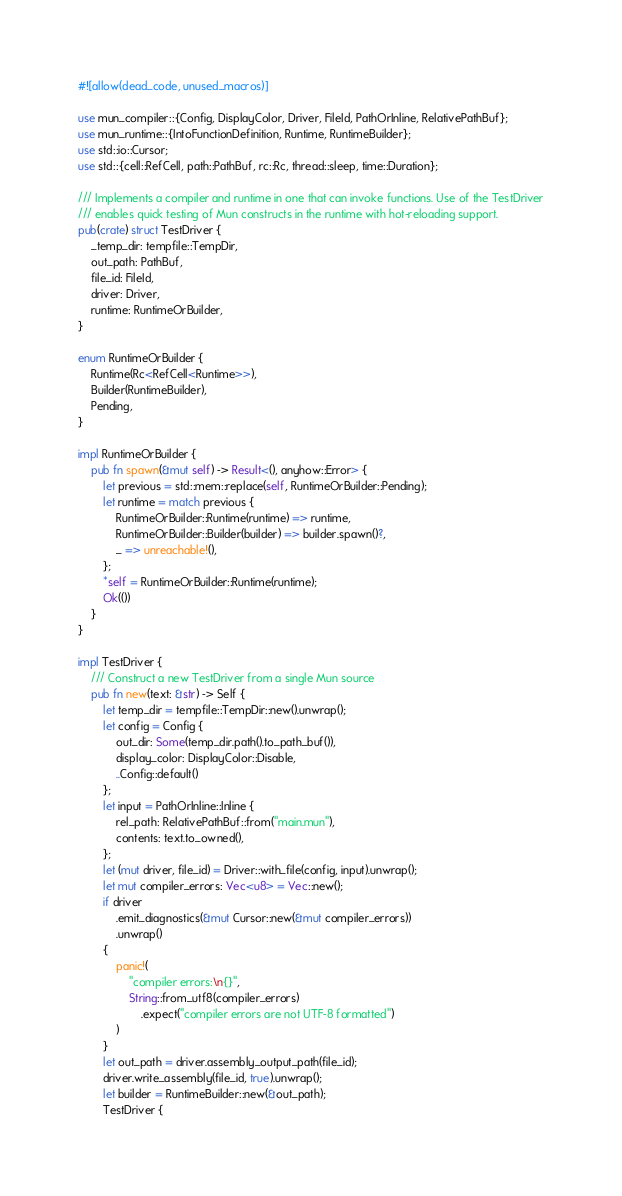<code> <loc_0><loc_0><loc_500><loc_500><_Rust_>#![allow(dead_code, unused_macros)]

use mun_compiler::{Config, DisplayColor, Driver, FileId, PathOrInline, RelativePathBuf};
use mun_runtime::{IntoFunctionDefinition, Runtime, RuntimeBuilder};
use std::io::Cursor;
use std::{cell::RefCell, path::PathBuf, rc::Rc, thread::sleep, time::Duration};

/// Implements a compiler and runtime in one that can invoke functions. Use of the TestDriver
/// enables quick testing of Mun constructs in the runtime with hot-reloading support.
pub(crate) struct TestDriver {
    _temp_dir: tempfile::TempDir,
    out_path: PathBuf,
    file_id: FileId,
    driver: Driver,
    runtime: RuntimeOrBuilder,
}

enum RuntimeOrBuilder {
    Runtime(Rc<RefCell<Runtime>>),
    Builder(RuntimeBuilder),
    Pending,
}

impl RuntimeOrBuilder {
    pub fn spawn(&mut self) -> Result<(), anyhow::Error> {
        let previous = std::mem::replace(self, RuntimeOrBuilder::Pending);
        let runtime = match previous {
            RuntimeOrBuilder::Runtime(runtime) => runtime,
            RuntimeOrBuilder::Builder(builder) => builder.spawn()?,
            _ => unreachable!(),
        };
        *self = RuntimeOrBuilder::Runtime(runtime);
        Ok(())
    }
}

impl TestDriver {
    /// Construct a new TestDriver from a single Mun source
    pub fn new(text: &str) -> Self {
        let temp_dir = tempfile::TempDir::new().unwrap();
        let config = Config {
            out_dir: Some(temp_dir.path().to_path_buf()),
            display_color: DisplayColor::Disable,
            ..Config::default()
        };
        let input = PathOrInline::Inline {
            rel_path: RelativePathBuf::from("main.mun"),
            contents: text.to_owned(),
        };
        let (mut driver, file_id) = Driver::with_file(config, input).unwrap();
        let mut compiler_errors: Vec<u8> = Vec::new();
        if driver
            .emit_diagnostics(&mut Cursor::new(&mut compiler_errors))
            .unwrap()
        {
            panic!(
                "compiler errors:\n{}",
                String::from_utf8(compiler_errors)
                    .expect("compiler errors are not UTF-8 formatted")
            )
        }
        let out_path = driver.assembly_output_path(file_id);
        driver.write_assembly(file_id, true).unwrap();
        let builder = RuntimeBuilder::new(&out_path);
        TestDriver {</code> 